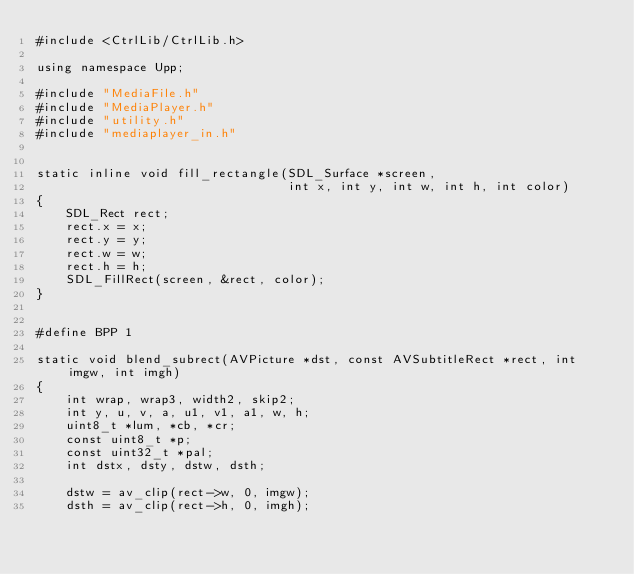<code> <loc_0><loc_0><loc_500><loc_500><_C++_>#include <CtrlLib/CtrlLib.h>

using namespace Upp;

#include "MediaFile.h"
#include "MediaPlayer.h"
#include "utility.h"
#include "mediaplayer_in.h"


static inline void fill_rectangle(SDL_Surface *screen,
                                  int x, int y, int w, int h, int color)
{
    SDL_Rect rect;
    rect.x = x;
    rect.y = y;
    rect.w = w;
    rect.h = h;
    SDL_FillRect(screen, &rect, color);
}


#define BPP 1

static void blend_subrect(AVPicture *dst, const AVSubtitleRect *rect, int imgw, int imgh)
{
    int wrap, wrap3, width2, skip2;
    int y, u, v, a, u1, v1, a1, w, h;
    uint8_t *lum, *cb, *cr;
    const uint8_t *p;
    const uint32_t *pal;
    int dstx, dsty, dstw, dsth;

    dstw = av_clip(rect->w, 0, imgw);
    dsth = av_clip(rect->h, 0, imgh);</code> 